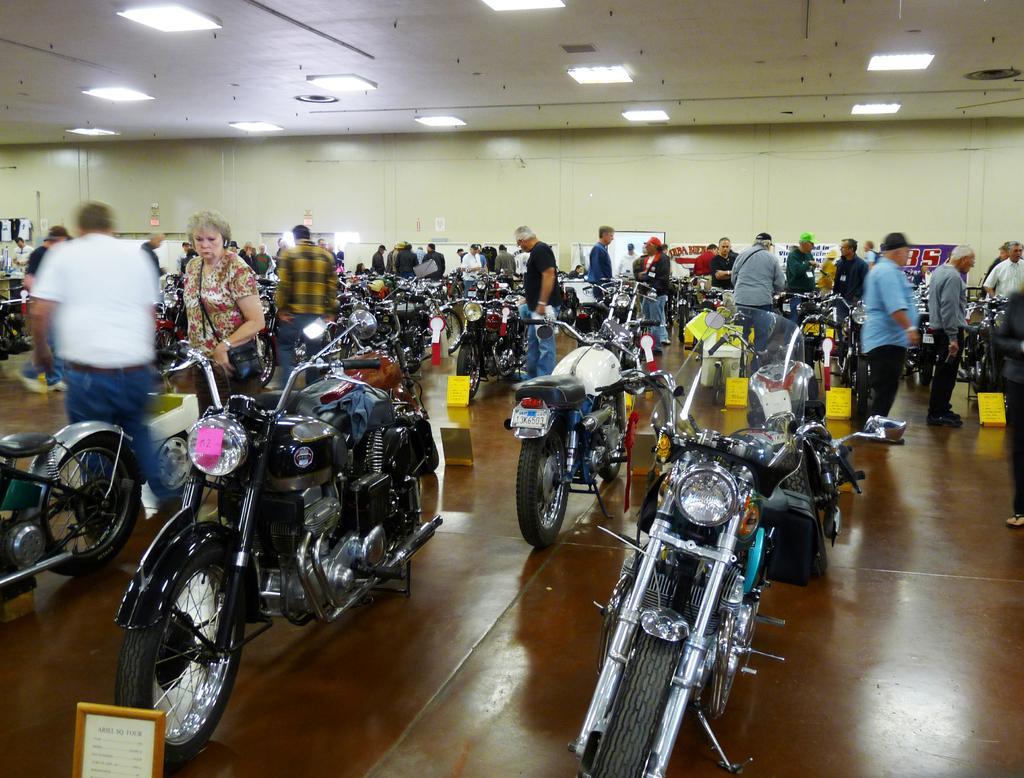Can you describe this image briefly? This is looking like a motorcycle exhibition. Here we can see a few people who are standing and watching these motorcycles. This is a roof with lightning arrangement. 